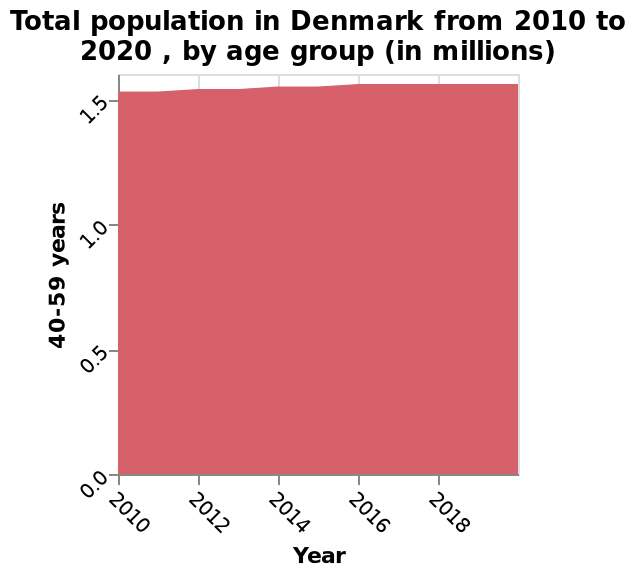<image>
Did the population of 40-59 year olds change from 2016 to 2020?  No, the population of 40-59 year olds stayed the same from 2016 to 2020. What is the title of the area diagram based on the given figure? The title of the area diagram is "Total population in Denmark from 2010 to 2020, by age group (in millions)." What is the variable represented along the x-axis of the area diagram? The x-axis of the area diagram represents the years from 2010 to 2020. Offer a thorough analysis of the image. The population of 40-59 year olds rose slightly from 2010 to 2016. The population of 40-59 year olds stayed the same from 2016 to 2020. The population of 40-59 year olds has not risen much above 1.5 during the time frame. Has the population of 40-59 year olds exceeded 1.5 during the given time frame?  No, the population of 40-59 year olds has not risen much above 1.5 during the time frame. 